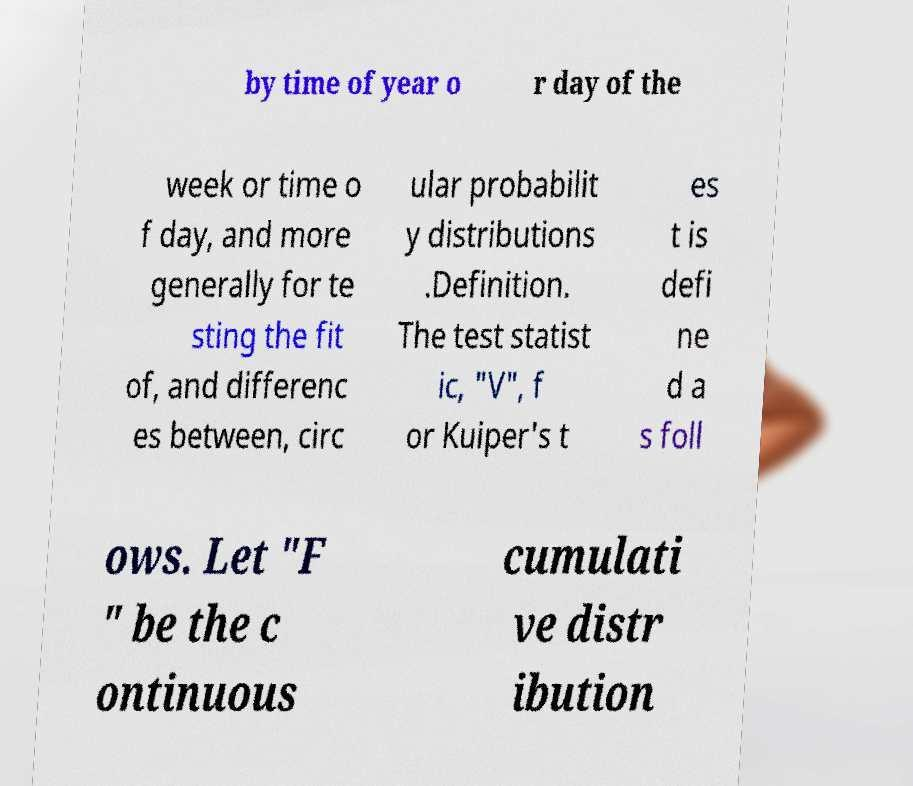I need the written content from this picture converted into text. Can you do that? by time of year o r day of the week or time o f day, and more generally for te sting the fit of, and differenc es between, circ ular probabilit y distributions .Definition. The test statist ic, "V", f or Kuiper's t es t is defi ne d a s foll ows. Let "F " be the c ontinuous cumulati ve distr ibution 